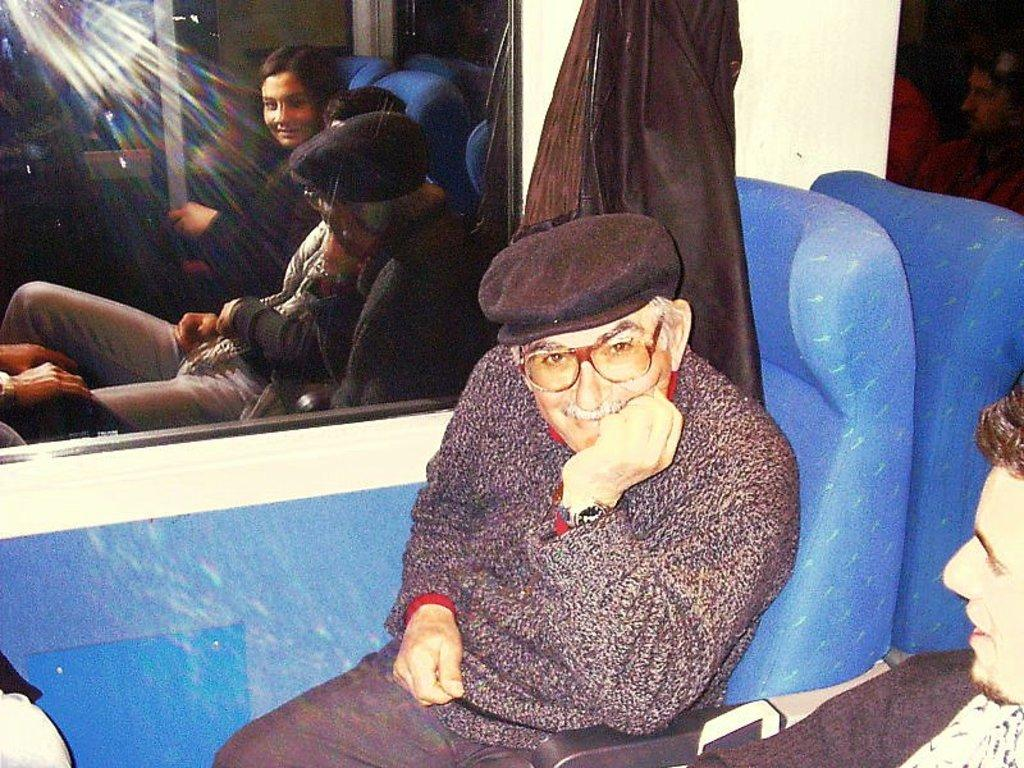How many people are present in the image? There are two persons sitting in the image. What can be seen in the background of the image? There is a window in the background of the image. What color is the wall in the image? The wall is in white color. What type of chicken is sitting on the grandmother's lap in the image? There is no chicken or grandmother present in the image. 